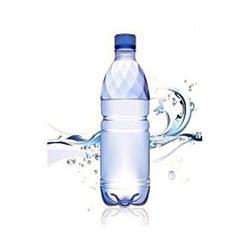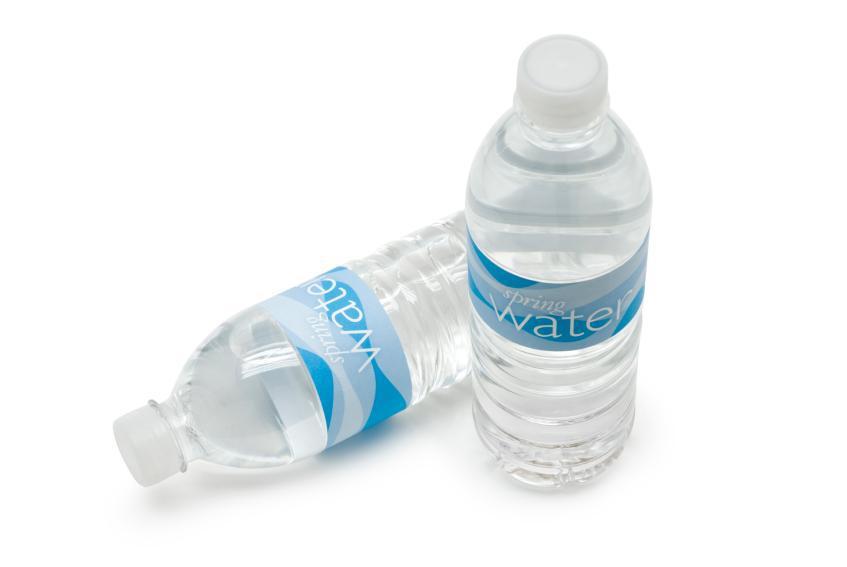The first image is the image on the left, the second image is the image on the right. For the images shown, is this caption "There is a bottle laying sideways in one of the images." true? Answer yes or no. Yes. The first image is the image on the left, the second image is the image on the right. Examine the images to the left and right. Is the description "An image shows an upright water bottle next to one lying on its side." accurate? Answer yes or no. Yes. 